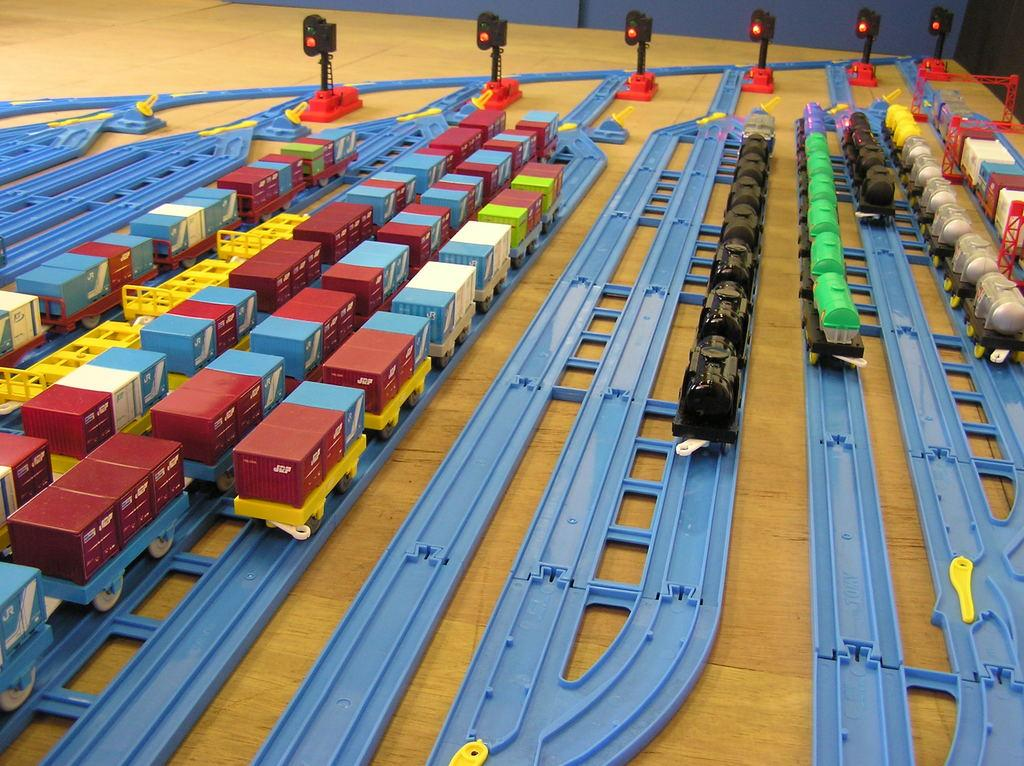What type of toy is present on the tracks in the image? There are toy trains on tracks in the image. What other objects can be seen in the image? There are traffic signals with poles in the image. What color is the background of the image? The background of the image is blue. Can you tell me who won the argument between the toy trains in the image? There is no argument between the toy trains in the image, as they are inanimate objects and cannot engage in arguments. 